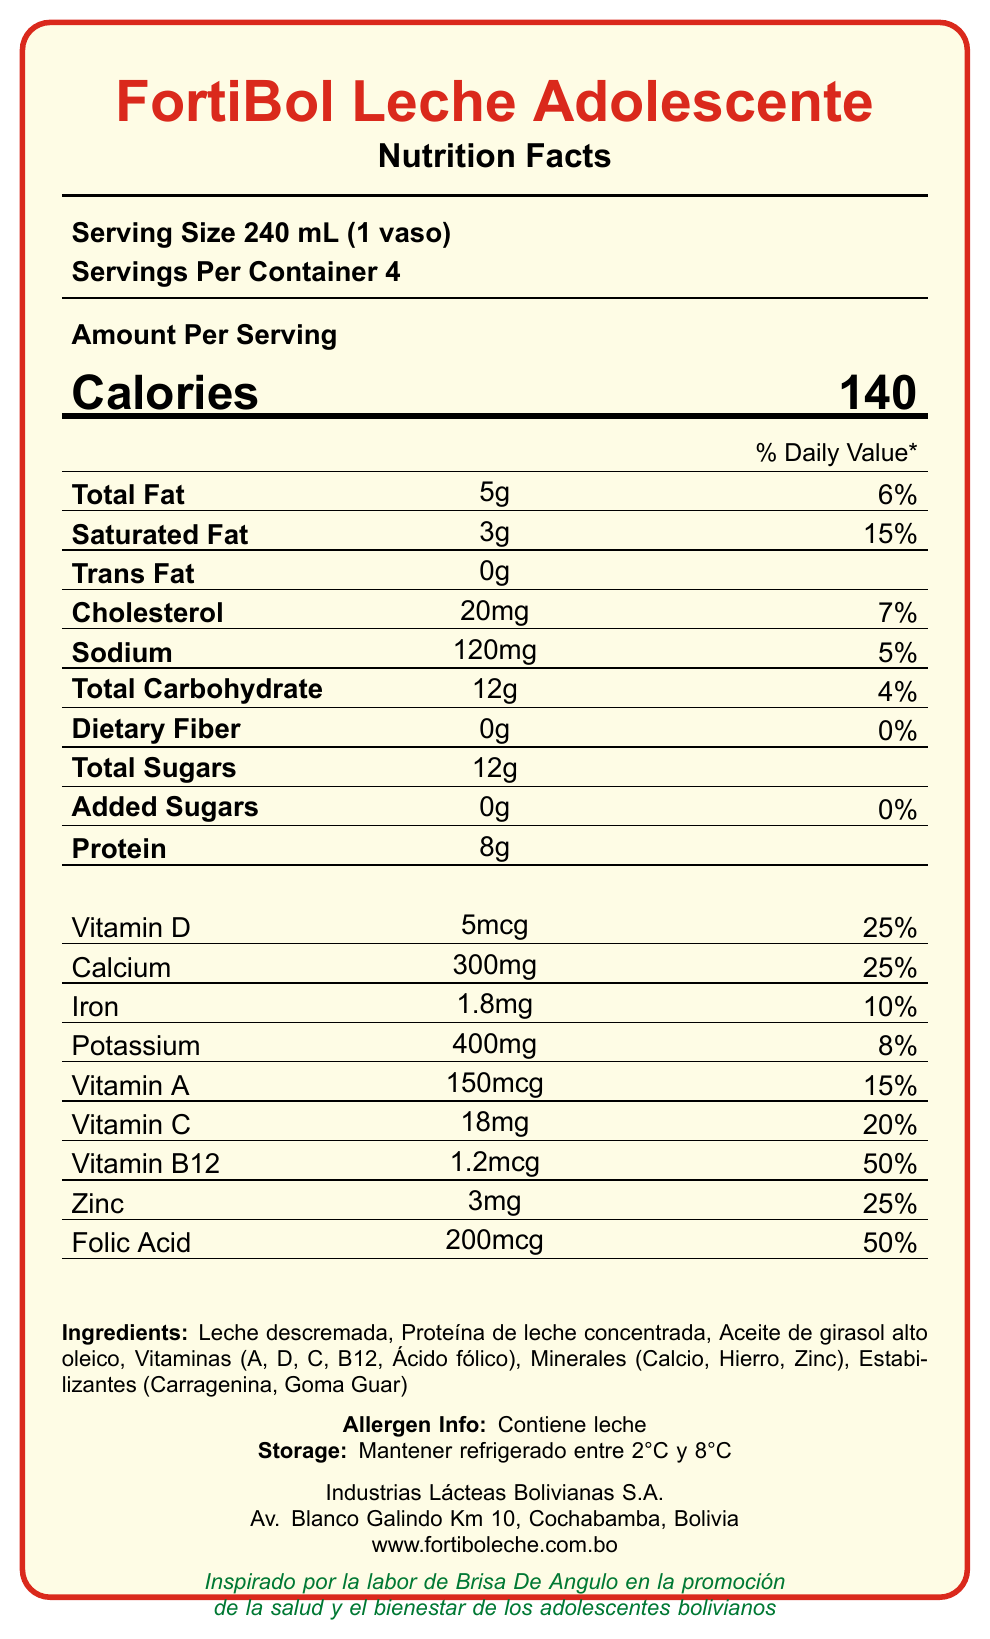what is the serving size for FortiBol Leche Adolescente? The document specifies "Serving Size 240 mL (1 vaso)" at the top of the Nutrition Facts.
Answer: 240 mL (1 vaso) how many calories are there per serving? The document lists "Calories 140" under the "Amount Per Serving" section.
Answer: 140 what percentage of the daily value is provided by the saturated fat in one serving? The document shows "Saturated Fat 3g" with "15%" as the daily value percentage.
Answer: 15% what is the total carbohydrate content per serving and its daily value percentage? The document states "Total Carbohydrate 12g" with a daily value of "4%".
Answer: 12g, 4% which vitamins and minerals provide 25% of the daily value per serving? A. Calcium, Zinc, Vitamin C B. Vitamin D, Calcium, Zinc C. Vitamin A, Vitamin B12, Folic Acid The document specifies that Vitamin D, Calcium, and Zinc each have a daily value of 25%.
Answer: B what are the main ingredients of FortiBol Leche Adolescente? The list of ingredients is detailed at the bottom under "Ingredients".
Answer: Leche descremada, Proteína de leche concentrada, Aceite de girasol alto oleico, Vitaminas (A, D, C, B12, Ácido fólico), Minerales (Calcio, Hierro, Zinc), Estabilizantes (Carragenina, Goma Guar) what must the storage temperature be for this product? The storage instructions state "Mantener refrigerado entre 2°C y 8°C".
Answer: Between 2°C and 8°C how much protein does one serving contain? The document lists "Protein 8g" under the nutritional information.
Answer: 8g which vitamin provides the highest daily value percentage per serving? A. Vitamin D B. Vitamin C C. Vitamin B12 D. Vitamin A The document shows "Vitamin B12 1.2mcg" providing "50%" of the daily value.
Answer: C does FortiBol Leche Adolescente contain any added sugars? The document lists "Added Sugars 0g" and "0%" daily value, indicating no added sugars.
Answer: No is the product allergen-free? The allergen information states "Contiene leche," indicating it contains milk.
Answer: No summarize the main nutritional benefits of FortiBol Leche Adolescente. The document highlights the nutrition facts, showing that this fortified milk product is rich in several key vitamins and minerals that support adolescent growth and health.
Answer: FortiBol Leche Adolescente provides essential nutrients for adolescents including 140 calories per serving, 5g of total fat, 12g of carbohydrates with 12g sugars, and 8g protein. It is fortified with various vitamins and minerals such as Vitamin D, Calcium, Iron, Potassium, Vitamin A, Vitamin C, Vitamin B12, Zinc, and Folic Acid, making it beneficial for adolescent health. what color are the borders and main text in the document? The document uses bolivian red for the borders and various colors for text to highlight different sections and provide visual appeal.
Answer: Bolivian red and various colors what are some of the additives used as stabilizers in FortiBol Leche Adolescente? The stabilizers listed in the ingredients are Carragenina and Goma Guar.
Answer: Carragenina, Goma Guar is the product suitable for someone with a milk allergy? The allergen information clearly states "Contiene leche," indicating it is not suitable for someone with a milk allergy.
Answer: No what is the amount of Vitamin C provided per serving? The document lists "Vitamin C 18mg" with a daily value of "20%".
Answer: 18mg, 20% how many servings are there in one container? The document specifies "Servings Per Container 4".
Answer: 4 who is the manufacturer of FortiBol Leche Adolescente and where is it located? The information about the manufacturer and address is provided at the bottom of the document.
Answer: Industrias Lácteas Bolivianas S.A., Av. Blanco Galindo Km 10, Cochabamba, Bolivia what website can I visit to find more information about FortiBol Leche Adolescente? The document lists the website at the bottom, allowing for further information on the product.
Answer: www.fortiboleche.com.bo does the document provide information on how the product was inspired? At the bottom, it states: "Inspirado por la labor de Brisa De Angulo en la promoción de la salud y el bienestar de los adolescentes bolivianos".
Answer: Yes, inspired by Brisa De Angulo's work on adolescent health what is the daily value percentage of folic acid per serving? The document lists "Folic Acid 200mcg" with a daily value of "50%".
Answer: 50% does FortiBol Leche Adolescente contain any iron? If yes, how much? The document states "Iron 1.8mg" with a daily value of "10%".
Answer: Yes, 1.8mg how many grams of dietary fiber are in a serving? The document lists "Dietary Fiber 0g" with "0%" daily value.
Answer: 0g what is the address of the manufacturer of FortiBol Leche Adolescente? The address is at the bottom of the document under the manufacturer's details.
Answer: Av. Blanco Galindo Km 10, Cochabamba, Bolivia does the document contain information about certification or dietary claims such as organic or gluten-free? The document does not mention any certification or specific dietary claims like organic or gluten-free.
Answer: Not enough information 